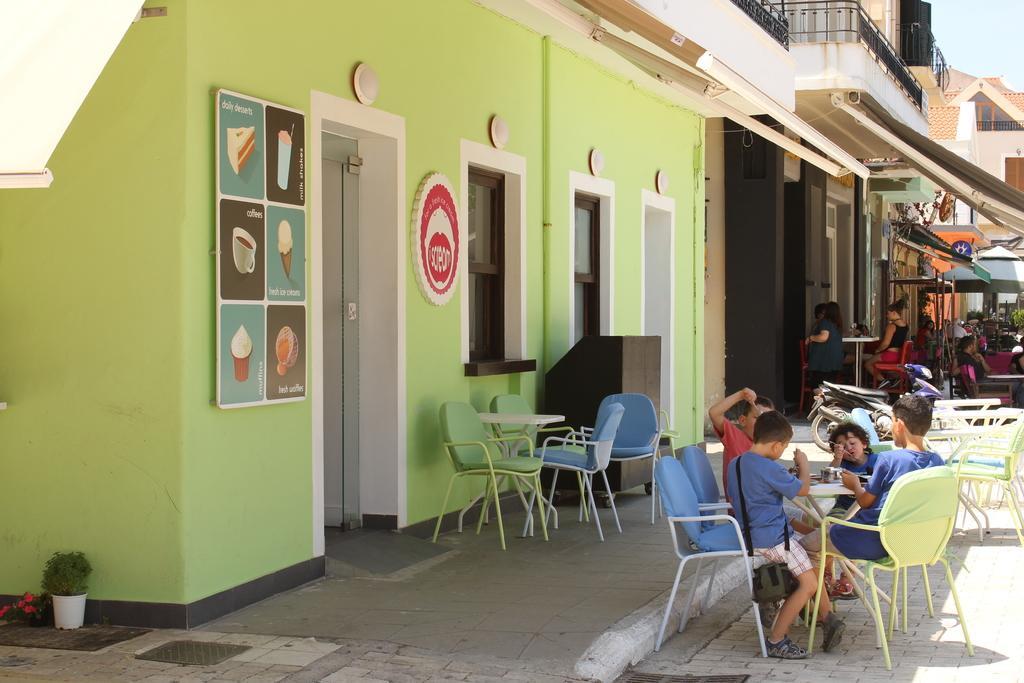Could you give a brief overview of what you see in this image? In the image on the right side we can see some persons were sitting around the table. And back of them we can see some peoples were sitting and standing. and coming to the background there is a building. 